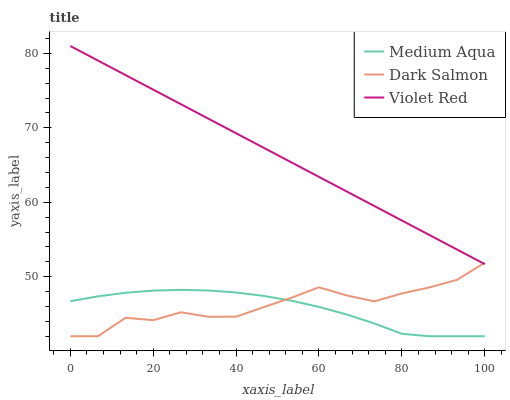Does Medium Aqua have the minimum area under the curve?
Answer yes or no. Yes. Does Violet Red have the maximum area under the curve?
Answer yes or no. Yes. Does Dark Salmon have the minimum area under the curve?
Answer yes or no. No. Does Dark Salmon have the maximum area under the curve?
Answer yes or no. No. Is Violet Red the smoothest?
Answer yes or no. Yes. Is Dark Salmon the roughest?
Answer yes or no. Yes. Is Medium Aqua the smoothest?
Answer yes or no. No. Is Medium Aqua the roughest?
Answer yes or no. No. Does Violet Red have the highest value?
Answer yes or no. Yes. Does Dark Salmon have the highest value?
Answer yes or no. No. Is Medium Aqua less than Violet Red?
Answer yes or no. Yes. Is Violet Red greater than Medium Aqua?
Answer yes or no. Yes. Does Dark Salmon intersect Medium Aqua?
Answer yes or no. Yes. Is Dark Salmon less than Medium Aqua?
Answer yes or no. No. Is Dark Salmon greater than Medium Aqua?
Answer yes or no. No. Does Medium Aqua intersect Violet Red?
Answer yes or no. No. 